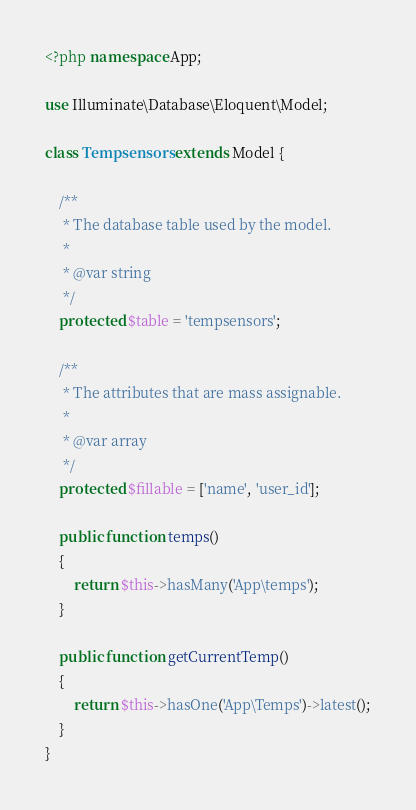Convert code to text. <code><loc_0><loc_0><loc_500><loc_500><_PHP_><?php namespace App;

use Illuminate\Database\Eloquent\Model;

class Tempsensors extends Model {

	/**
	 * The database table used by the model.
	 *
	 * @var string
	 */
	protected $table = 'tempsensors';

	/**
	 * The attributes that are mass assignable.
	 *
	 * @var array
	 */
	protected $fillable = ['name', 'user_id'];
	
	public function temps()
    {
        return $this->hasMany('App\temps');
    }

    public function getCurrentTemp()
    {
    	return $this->hasOne('App\Temps')->latest();
    }
}</code> 